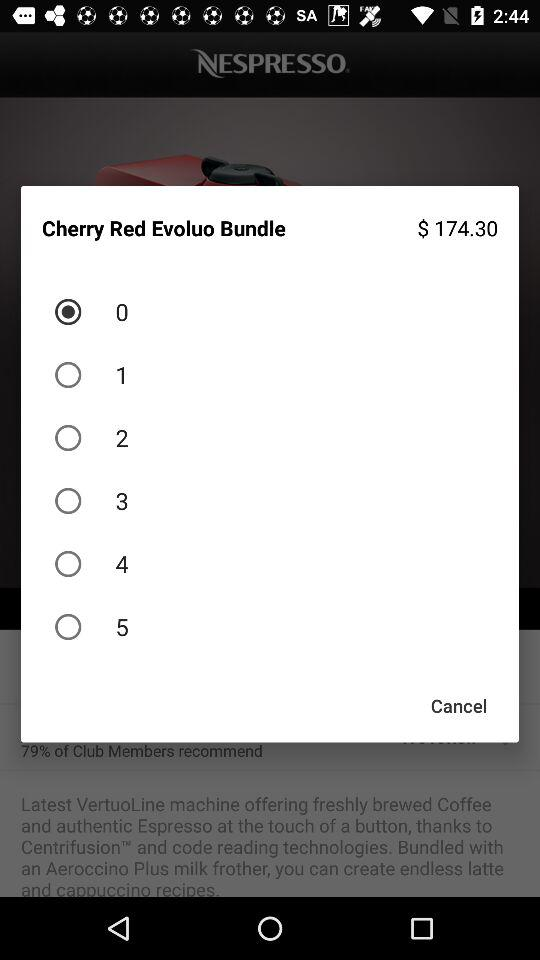Which option is selected? The selected option is "0". 